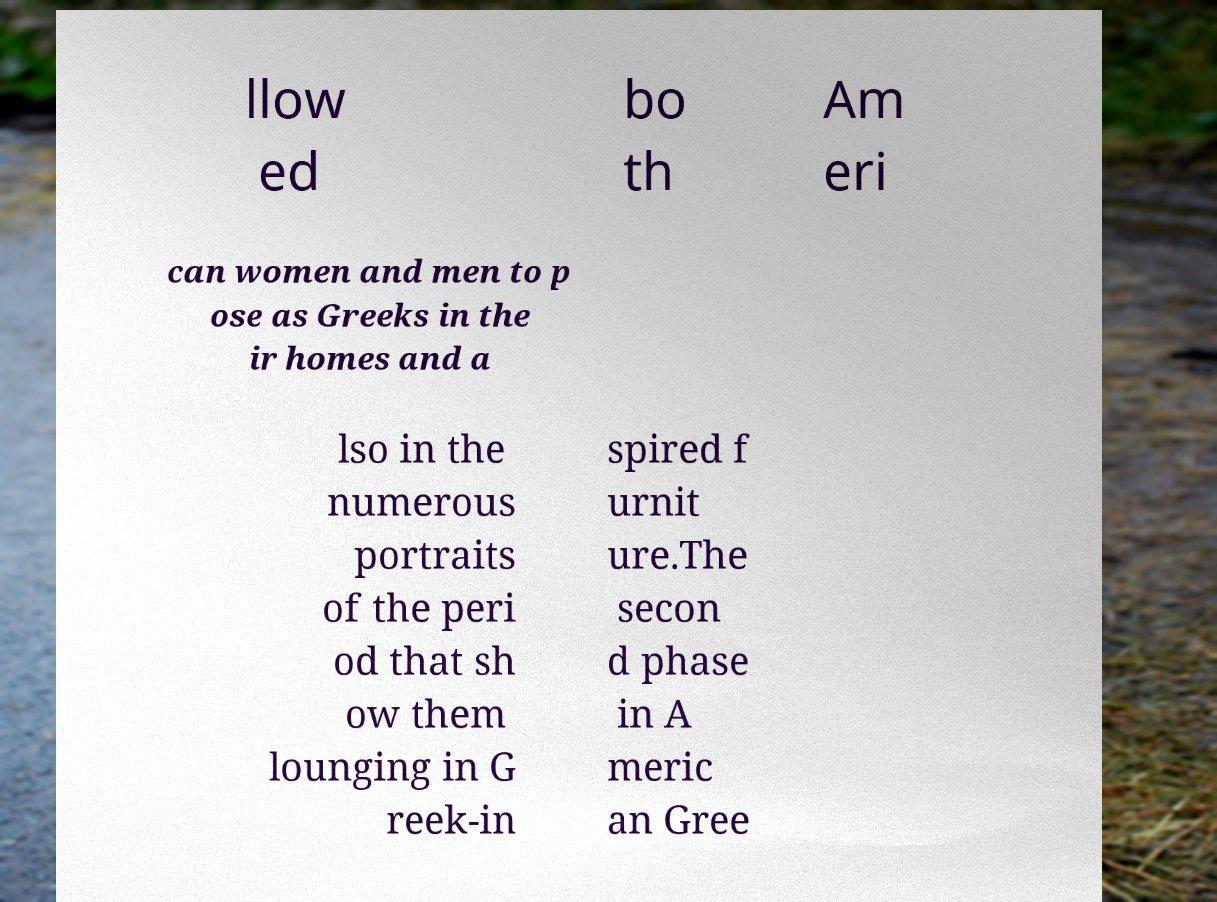Could you extract and type out the text from this image? llow ed bo th Am eri can women and men to p ose as Greeks in the ir homes and a lso in the numerous portraits of the peri od that sh ow them lounging in G reek-in spired f urnit ure.The secon d phase in A meric an Gree 